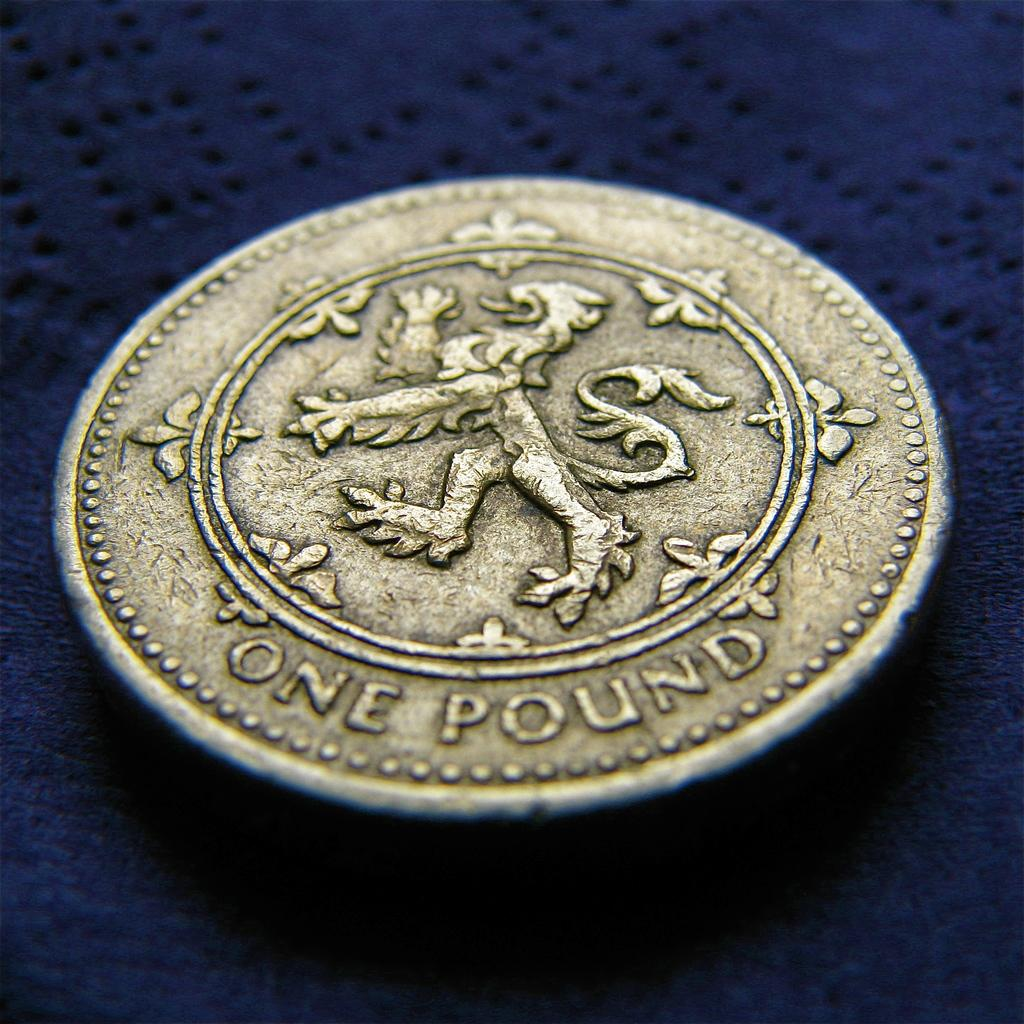Provide a one-sentence caption for the provided image. A pound sterling in the form of a golden coin is on top of a blue cloth. 